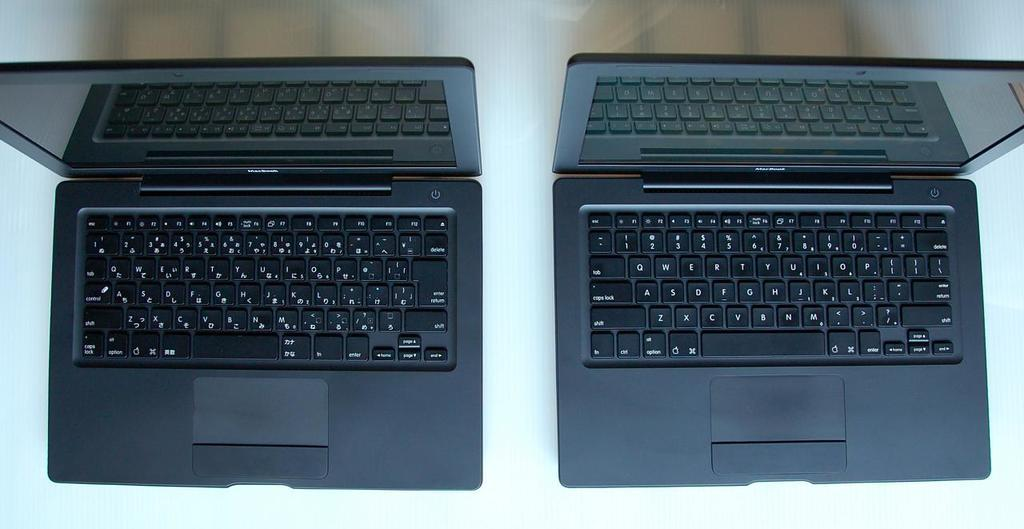How many laptops are visible in the image? There are two laptops in the image. Where are the laptops located? The laptops are on a platform. What type of coat is draped over the laptops in the image? There is no coat present in the image; it only features two laptops on a platform. 